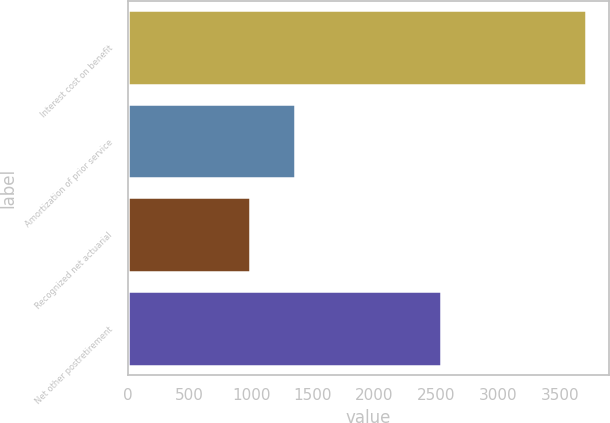Convert chart. <chart><loc_0><loc_0><loc_500><loc_500><bar_chart><fcel>Interest cost on benefit<fcel>Amortization of prior service<fcel>Recognized net actuarial<fcel>Net other postretirement<nl><fcel>3716<fcel>1359<fcel>988<fcel>2541<nl></chart> 